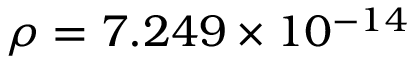<formula> <loc_0><loc_0><loc_500><loc_500>\rho = 7 . 2 4 9 \times 1 0 ^ { - 1 4 }</formula> 